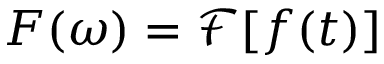Convert formula to latex. <formula><loc_0><loc_0><loc_500><loc_500>F ( \omega ) = \mathcal { F } [ f ( t ) ]</formula> 